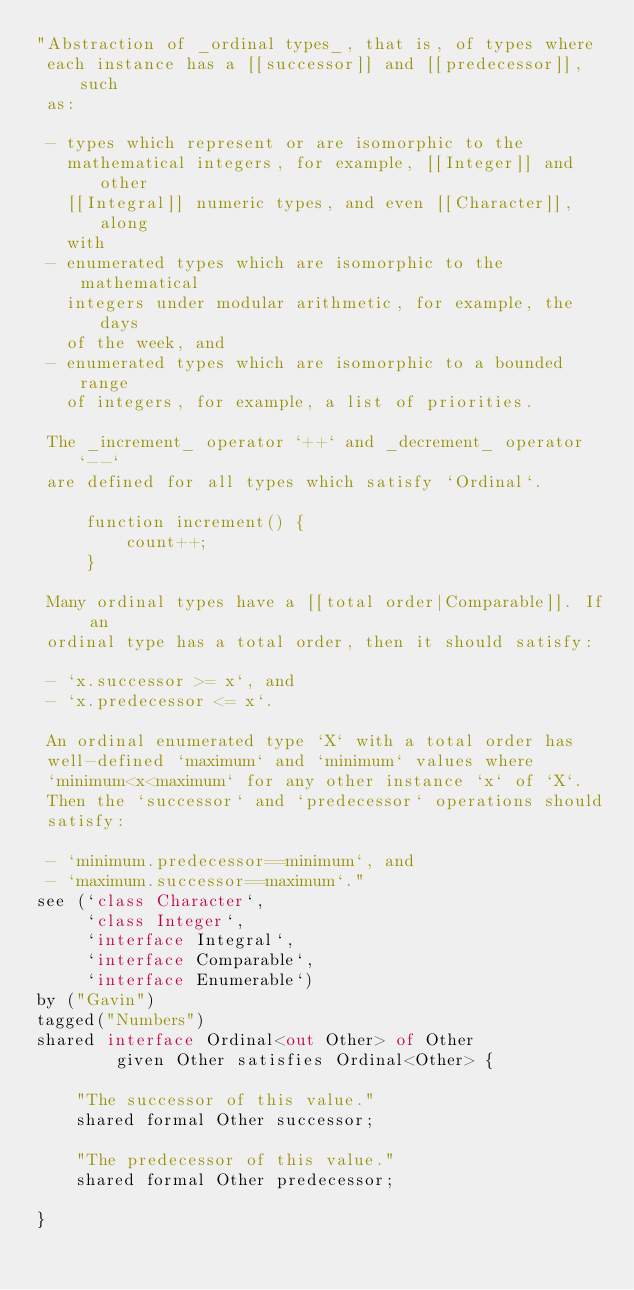<code> <loc_0><loc_0><loc_500><loc_500><_Ceylon_>"Abstraction of _ordinal types_, that is, of types where 
 each instance has a [[successor]] and [[predecessor]], such 
 as:
  
 - types which represent or are isomorphic to the 
   mathematical integers, for example, [[Integer]] and other 
   [[Integral]] numeric types, and even [[Character]], along 
   with
 - enumerated types which are isomorphic to the mathematical
   integers under modular arithmetic, for example, the days
   of the week, and
 - enumerated types which are isomorphic to a bounded range 
   of integers, for example, a list of priorities.
 
 The _increment_ operator `++` and _decrement_ operator `--`
 are defined for all types which satisfy `Ordinal`.
 
     function increment() {
         count++;
     }
 
 Many ordinal types have a [[total order|Comparable]]. If an
 ordinal type has a total order, then it should satisfy:
 
 - `x.successor >= x`, and
 - `x.predecessor <= x`.
 
 An ordinal enumerated type `X` with a total order has 
 well-defined `maximum` and `minimum` values where
 `minimum<x<maximum` for any other instance `x` of `X`.
 Then the `successor` and `predecessor` operations should
 satisfy:
 
 - `minimum.predecessor==minimum`, and
 - `maximum.successor==maximum`."
see (`class Character`, 
     `class Integer`, 
     `interface Integral`, 
     `interface Comparable`,
     `interface Enumerable`)
by ("Gavin")
tagged("Numbers")
shared interface Ordinal<out Other> of Other
        given Other satisfies Ordinal<Other> {
    
    "The successor of this value."
    shared formal Other successor;
    
    "The predecessor of this value."
    shared formal Other predecessor;
    
}
</code> 